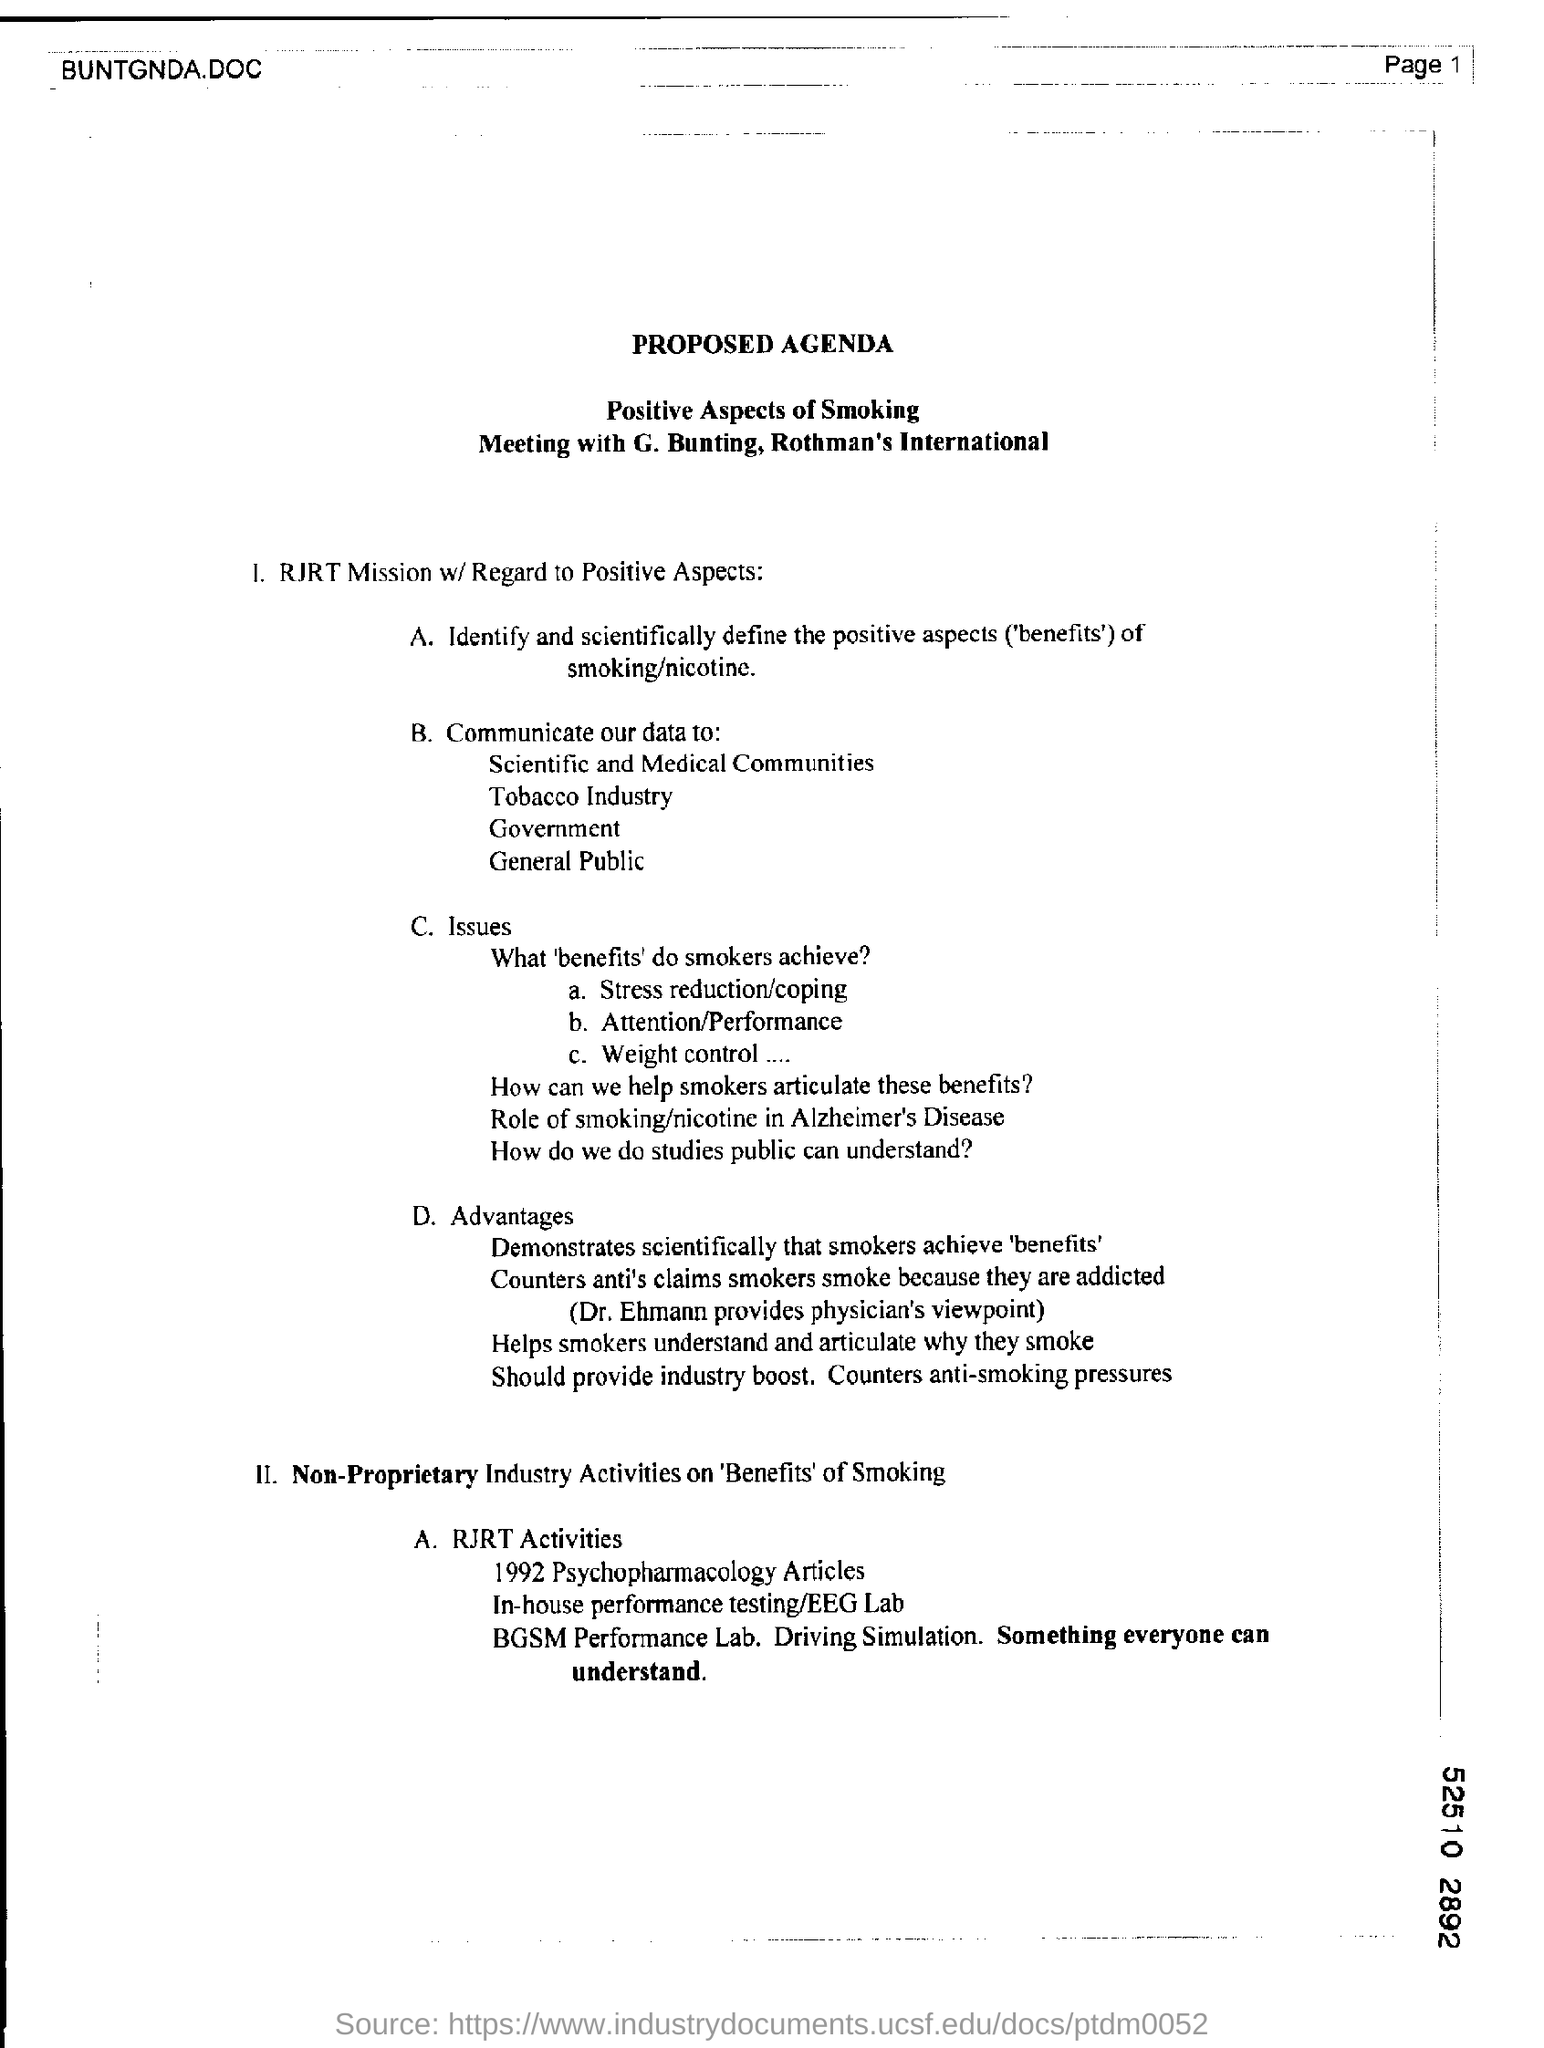Identify some key points in this picture. Please mention the page number at the top right corner of the page, starting from 1... The heading at the top of the page is 'Proposed Agenda.' 